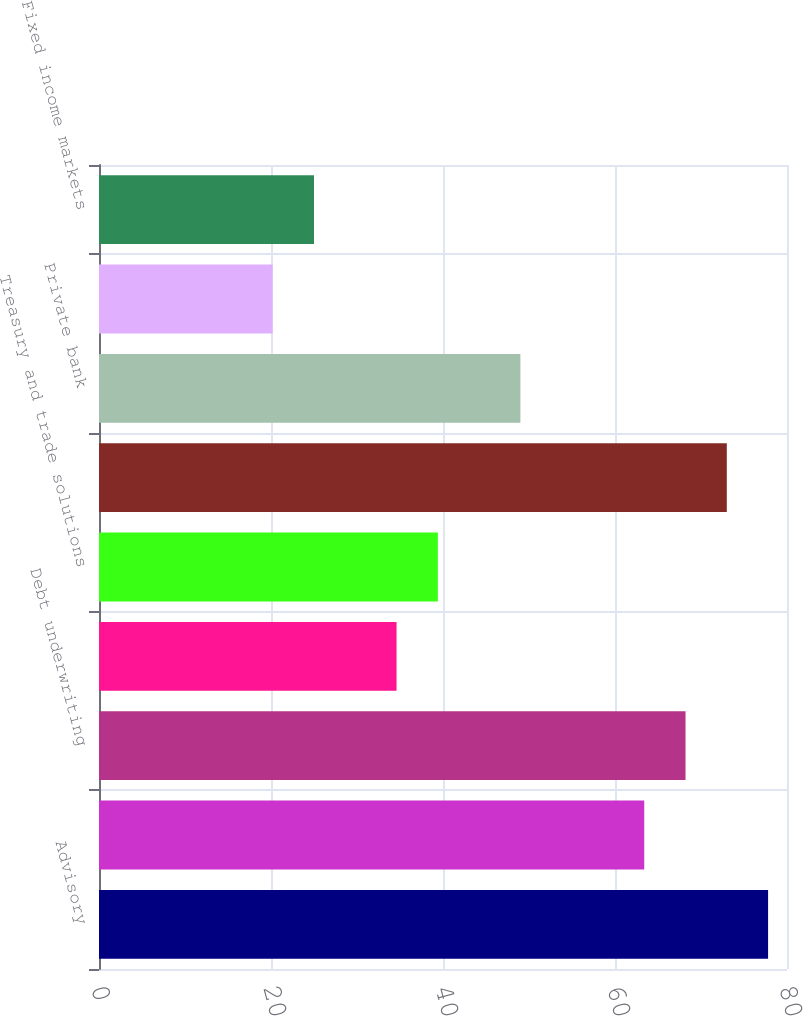Convert chart. <chart><loc_0><loc_0><loc_500><loc_500><bar_chart><fcel>Advisory<fcel>Equity underwriting<fcel>Debt underwriting<fcel>Total investment banking<fcel>Treasury and trade solutions<fcel>Corporate lending-excluding<fcel>Private bank<fcel>Total Banking revenues<fcel>Fixed income markets<nl><fcel>77.8<fcel>63.4<fcel>68.2<fcel>34.6<fcel>39.4<fcel>73<fcel>49<fcel>20.2<fcel>25<nl></chart> 